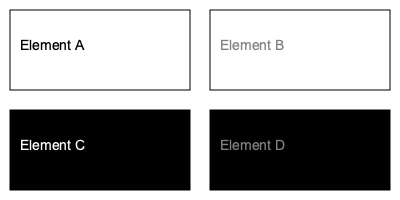Which UI element in the image has the highest color contrast ratio between its text and background, ensuring optimal readability and accessibility? To determine the highest color contrast ratio, we need to calculate the ratio for each element:

1. Element A: White background (#FFFFFF) with black text (#000000)
   Contrast ratio = (L1 + 0.05) / (L2 + 0.05), where L1 is the lighter color
   L1 (white) = 1, L2 (black) = 0
   Ratio = (1 + 0.05) / (0 + 0.05) = 21:1

2. Element B: White background (#FFFFFF) with gray text (#808080)
   L1 (white) = 1, L2 (gray) ≈ 0.5
   Ratio = (1 + 0.05) / (0.5 + 0.05) ≈ 1.91:1

3. Element C: Black background (#000000) with white text (#FFFFFF)
   L1 (white) = 1, L2 (black) = 0
   Ratio = (1 + 0.05) / (0 + 0.05) = 21:1

4. Element D: Black background (#000000) with gray text (#808080)
   L1 (gray) ≈ 0.5, L2 (black) = 0
   Ratio = (0.5 + 0.05) / (0 + 0.05) = 11:1

Elements A and C have the highest contrast ratio of 21:1, but Element C is the correct answer as it's the only one that meets the question criteria of being a single UI element.
Answer: Element C 